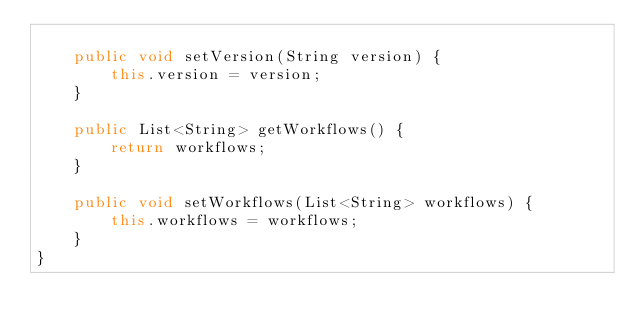Convert code to text. <code><loc_0><loc_0><loc_500><loc_500><_Java_>
    public void setVersion(String version) {
        this.version = version;
    }

    public List<String> getWorkflows() {
        return workflows;
    }

    public void setWorkflows(List<String> workflows) {
        this.workflows = workflows;
    }
}
</code> 